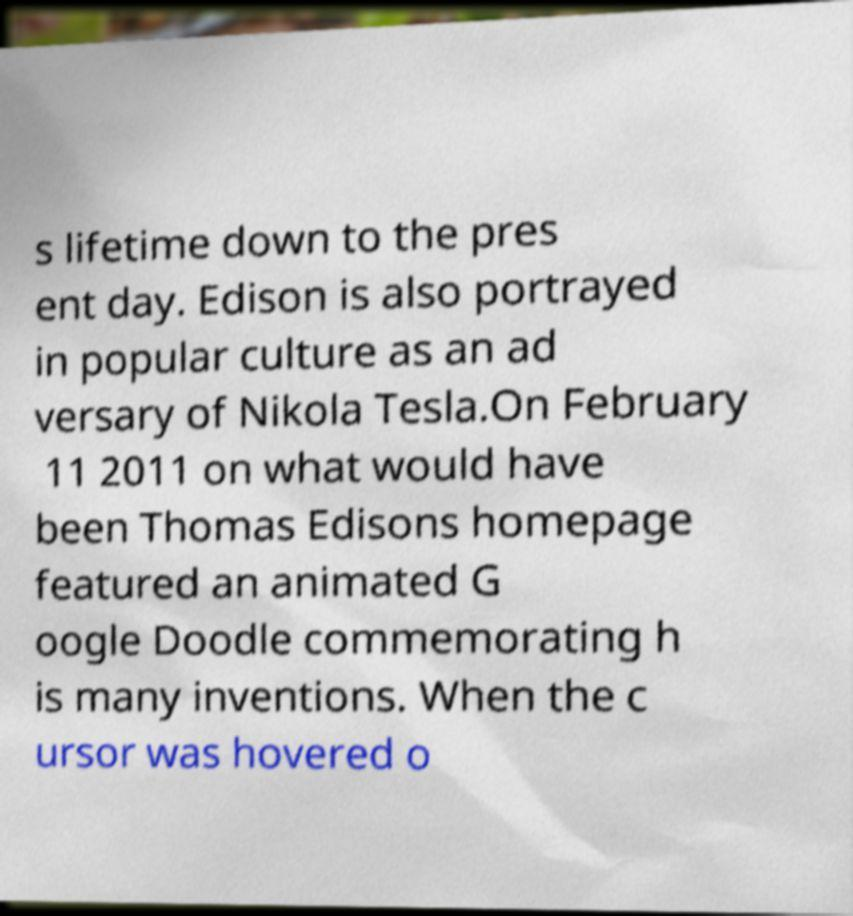Please read and relay the text visible in this image. What does it say? s lifetime down to the pres ent day. Edison is also portrayed in popular culture as an ad versary of Nikola Tesla.On February 11 2011 on what would have been Thomas Edisons homepage featured an animated G oogle Doodle commemorating h is many inventions. When the c ursor was hovered o 